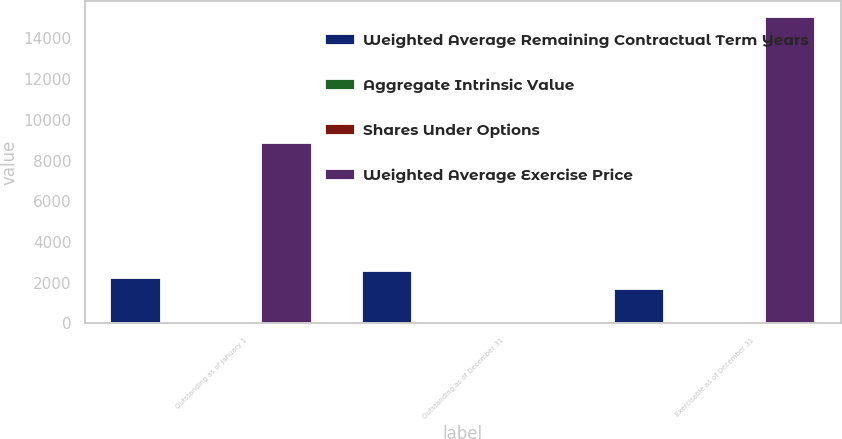Convert chart. <chart><loc_0><loc_0><loc_500><loc_500><stacked_bar_chart><ecel><fcel>Outstanding as of January 1<fcel>Outstanding as of December 31<fcel>Exercisable as of December 31<nl><fcel>Weighted Average Remaining Contractual Term Years<fcel>2222<fcel>2587<fcel>1681<nl><fcel>Aggregate Intrinsic Value<fcel>35.77<fcel>37<fcel>35.58<nl><fcel>Shares Under Options<fcel>5<fcel>5<fcel>3.4<nl><fcel>Weighted Average Exercise Price<fcel>8870<fcel>37<fcel>15062<nl></chart> 